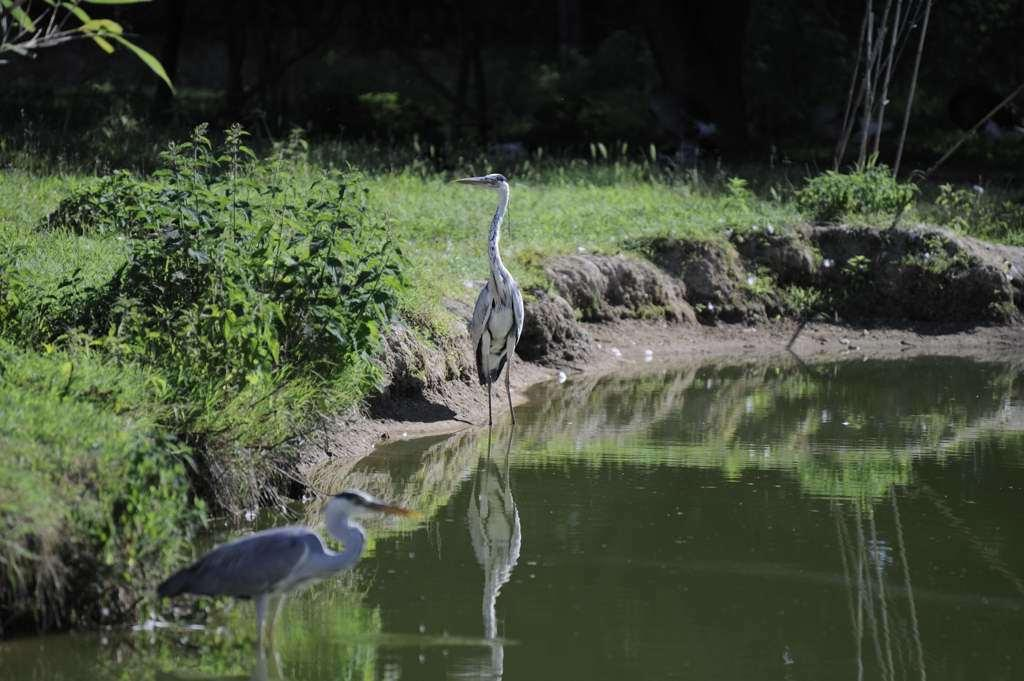How many birds are in the image? There are two birds in the image. Where are the birds located in the image? The birds are standing in water. What can be seen in the background of the image? There are plants and grass in the background of the image. How many goldfish are swimming in the water with the birds? There are no goldfish present in the image; it only features two birds standing in water. 